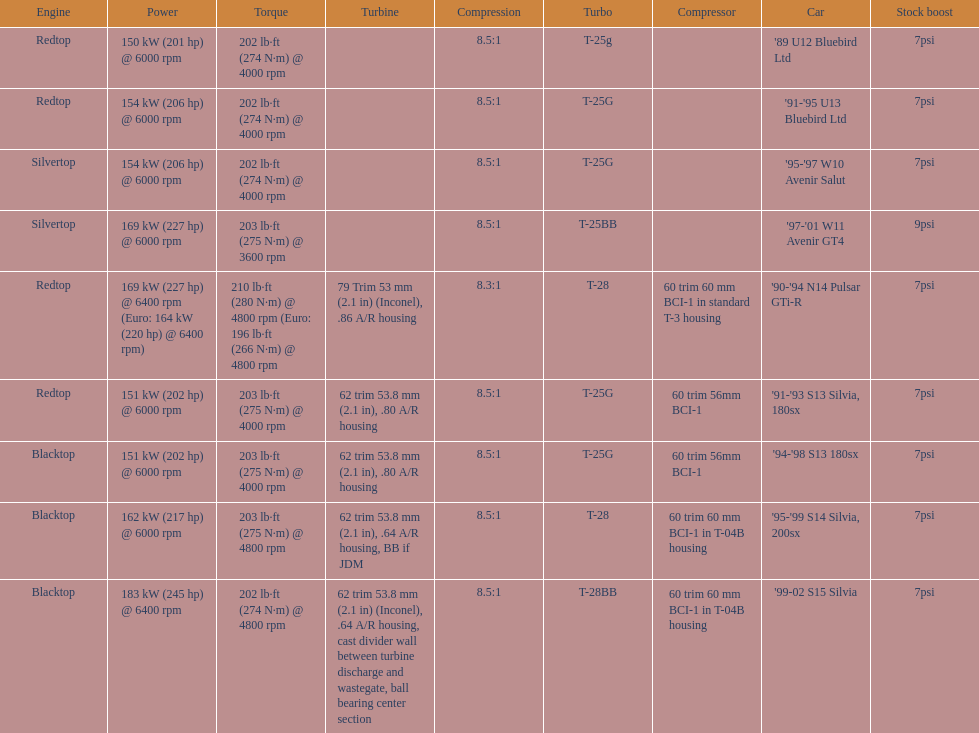Which vehicle is the sole one possessing over 230 horsepower? '99-02 S15 Silvia. 